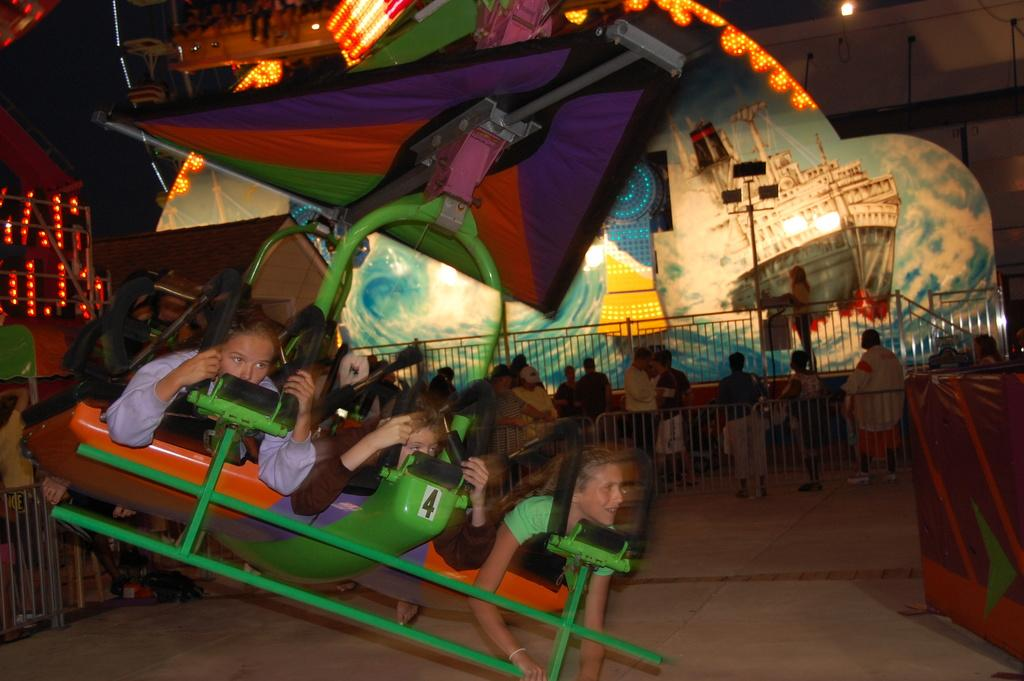What can be seen in the image involving children? There are kids in the image, and they are taking a ride in the exhibition. What is present in the image that might be used for safety or enclosure? There is a fence in the image. Who else can be seen in the image besides the kids? There are people in the image. Can you describe an unspecified object present in the image? Unfortunately, the provided facts do not give any details about the unspecified object, so it cannot be described. What type of songs are the kids singing while riding in the exhibition? There is no information about the kids singing songs in the image, so it cannot be determined. 